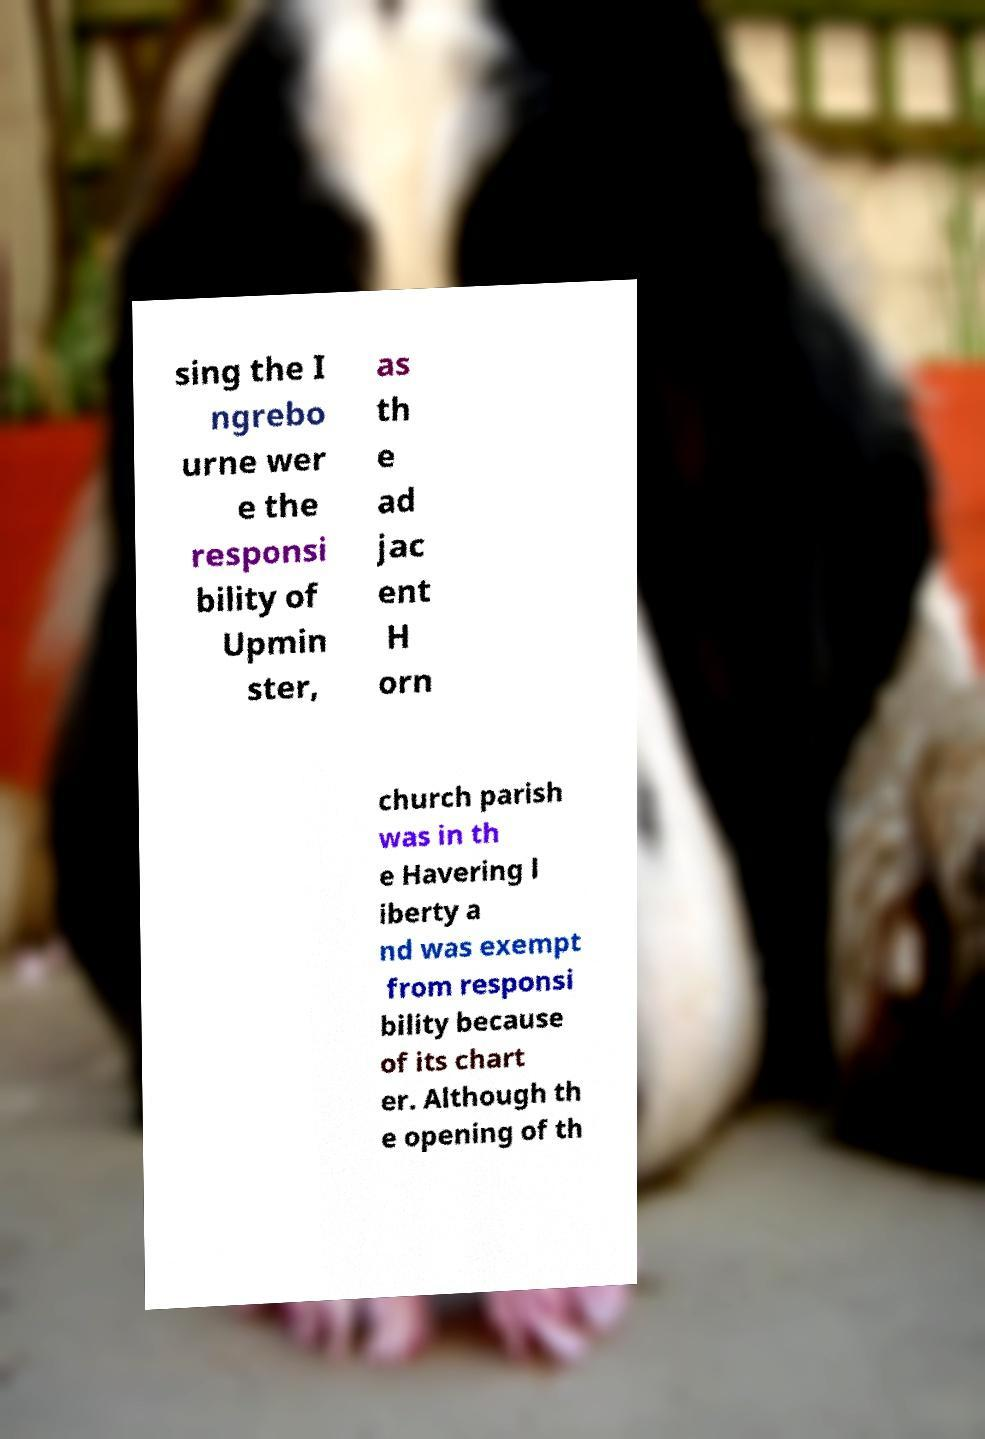Could you assist in decoding the text presented in this image and type it out clearly? sing the I ngrebo urne wer e the responsi bility of Upmin ster, as th e ad jac ent H orn church parish was in th e Havering l iberty a nd was exempt from responsi bility because of its chart er. Although th e opening of th 